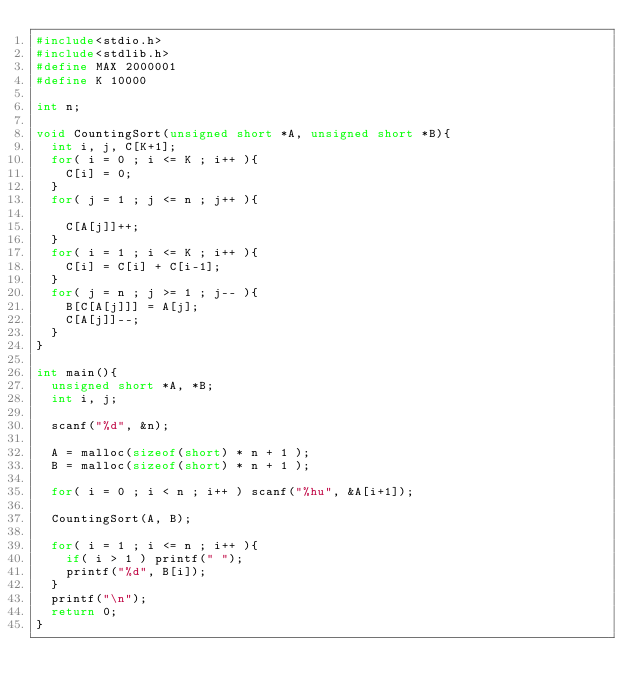Convert code to text. <code><loc_0><loc_0><loc_500><loc_500><_C_>#include<stdio.h>
#include<stdlib.h>
#define MAX 2000001
#define K 10000

int n;

void CountingSort(unsigned short *A, unsigned short *B){
  int i, j, C[K+1];
  for( i = 0 ; i <= K ; i++ ){
    C[i] = 0;
  }
  for( j = 1 ; j <= n ; j++ ){
    
    C[A[j]]++;
  }
  for( i = 1 ; i <= K ; i++ ){
    C[i] = C[i] + C[i-1];
  }
  for( j = n ; j >= 1 ; j-- ){
    B[C[A[j]]] = A[j];
    C[A[j]]--;
  }
}

int main(){
  unsigned short *A, *B;
  int i, j;
  
  scanf("%d", &n);

  A = malloc(sizeof(short) * n + 1 );
  B = malloc(sizeof(short) * n + 1 );

  for( i = 0 ; i < n ; i++ ) scanf("%hu", &A[i+1]);

  CountingSort(A, B);

  for( i = 1 ; i <= n ; i++ ){
    if( i > 1 ) printf(" ");
    printf("%d", B[i]);
  }
  printf("\n");
  return 0;
}

</code> 